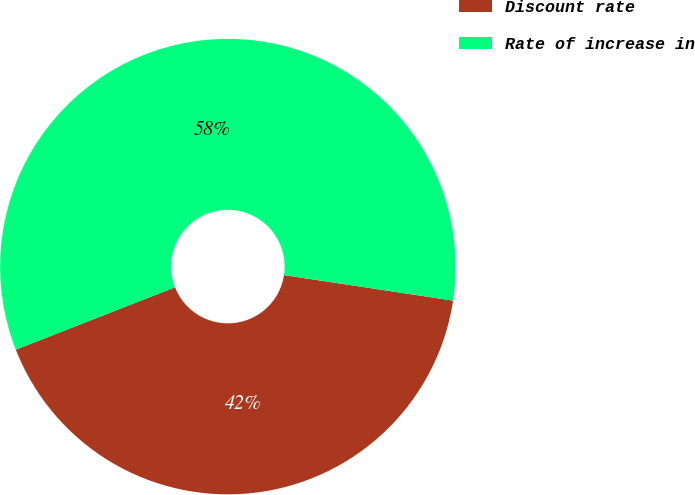<chart> <loc_0><loc_0><loc_500><loc_500><pie_chart><fcel>Discount rate<fcel>Rate of increase in<nl><fcel>41.67%<fcel>58.33%<nl></chart> 